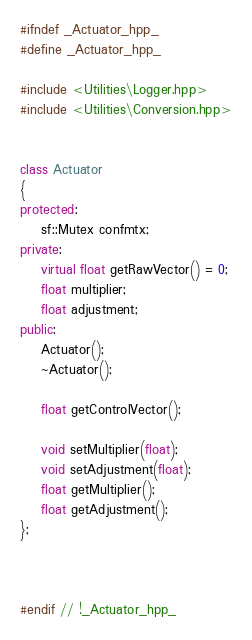<code> <loc_0><loc_0><loc_500><loc_500><_C++_>#ifndef _Actuator_hpp_
#define _Actuator_hpp_

#include <Utilities\Logger.hpp>
#include <Utilities\Conversion.hpp>


class Actuator
{
protected:
	sf::Mutex confmtx;
private:
	virtual float getRawVector() = 0;
	float multiplier;
	float adjustment;
public:
	Actuator();
	~Actuator();
	
	float getControlVector();

	void setMultiplier(float);
	void setAdjustment(float);
	float getMultiplier();
	float getAdjustment();
};



#endif // !_Actuator_hpp_
</code> 